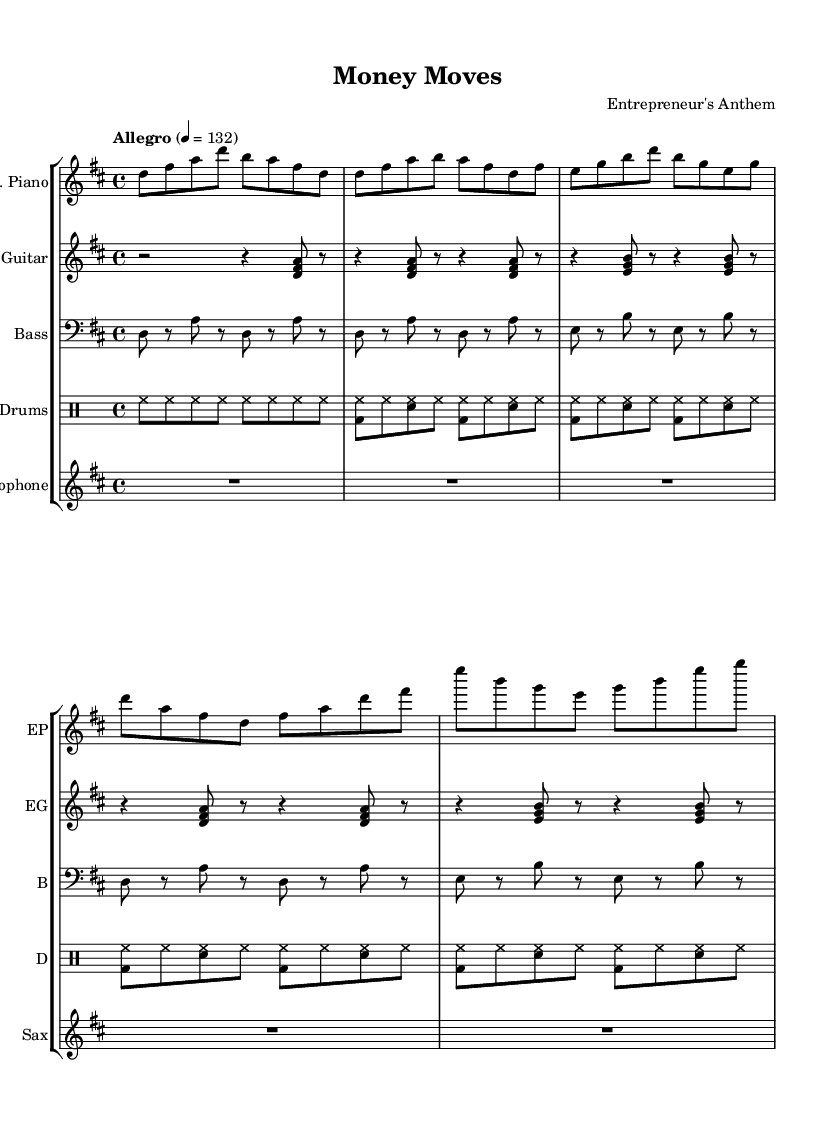What is the key signature of this music? The key signature is D major, indicated by the presence of two sharps (F# and C#) seen at the beginning of the staff.
Answer: D major What is the time signature of this music? The time signature is 4/4, which can be identified through the notation shown just after the key signature. It indicates that there are four beats in a measure and the quarter note gets one beat.
Answer: 4/4 What is the tempo marking for this piece? The tempo marking is "Allegro" with a metronome marking of 132, which suggests a fast pace for the music. This is noted directly above the staff.
Answer: Allegro How many measures are in the verse section? The verse section contains eight measures, which can be counted by identifying the groupings of notes and rests between the verses.
Answer: Eight What instruments are used in this piece? The instruments used are electric piano, electric guitar, bass, drums, and saxophone. This information can be found in the instrument names labeled above each staff.
Answer: Electric piano, electric guitar, bass, drums, saxophone What is the characteristic format of the rhythm in the chorus? The rhythm in the chorus often involves syncopation, particularly seen through the combination of bass drum and snare hits in a lively pattern that fits typical jazz-rock fusion styles.
Answer: Syncopation What genre does this piece exemplify? This piece exemplifies jazz-rock fusion, which can be deduced from the combination of jazz elements (such as syncopated rhythms) and rock characteristics (like the instrumentation and lively tempo).
Answer: Jazz-rock fusion 